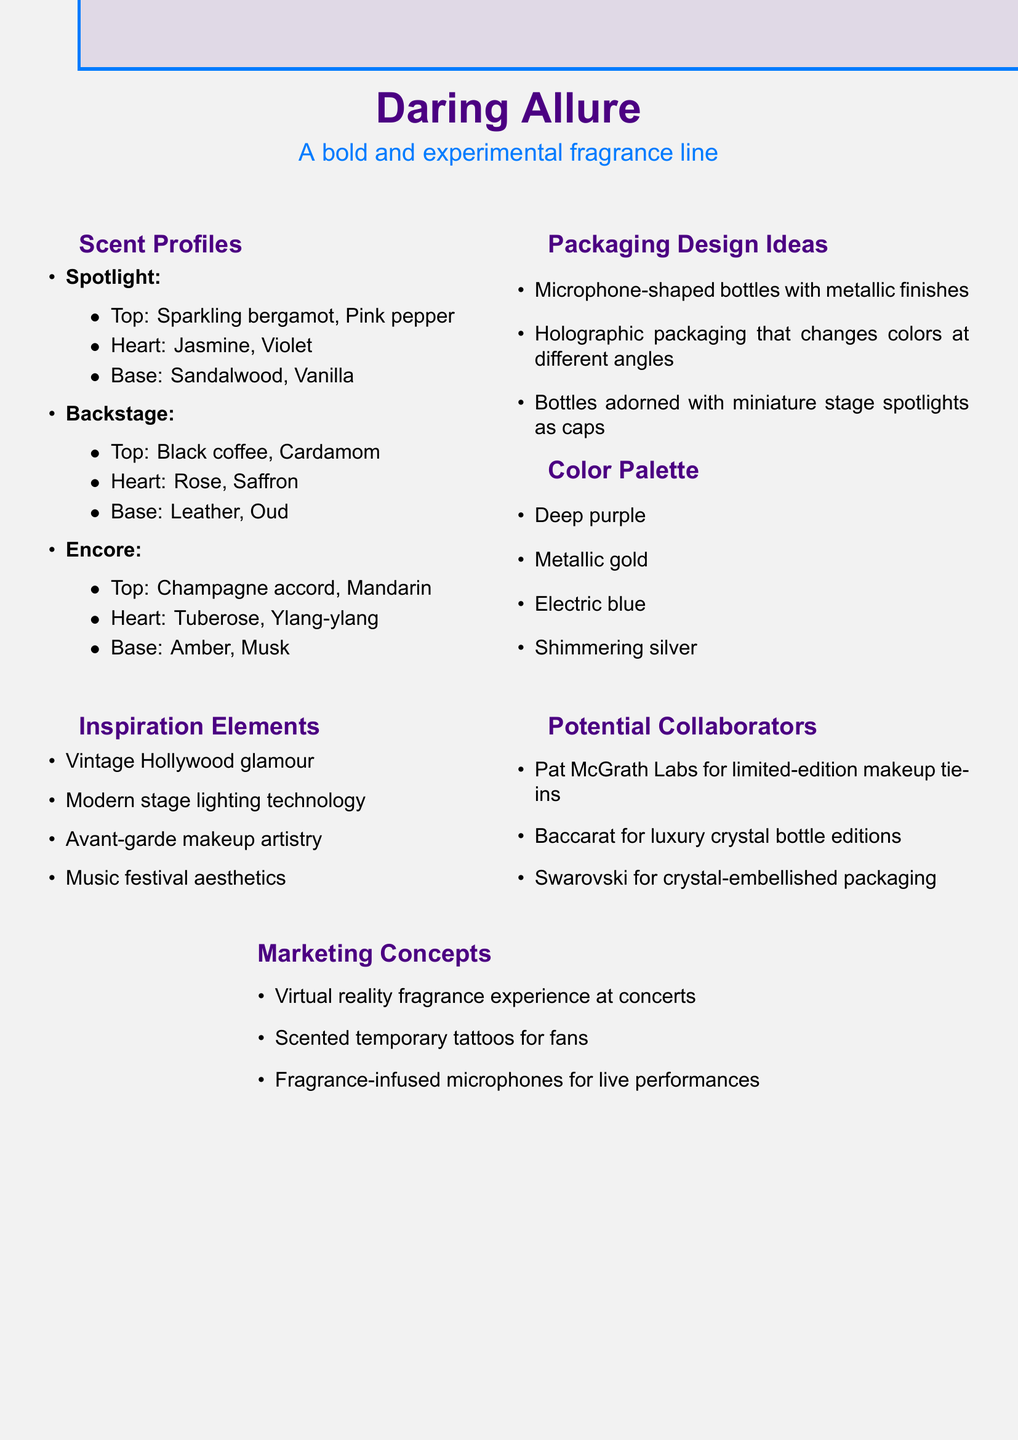What is the name of the fragrance line? The name of the fragrance line is presented prominently at the top of the document.
Answer: Daring Allure What are the top notes of the fragrance "Spotlight"? The top notes of "Spotlight" are found in the scent profiles section.
Answer: Sparkling bergamot, Pink pepper How many scent profiles are listed in the document? The number of scent profiles is determined by counting the items in the scent profiles section.
Answer: Three What is one of the packaging design ideas mentioned? A specific packaging design idea can be found in the packaging design ideas section.
Answer: Microphone-shaped bottles with metallic finishes Which color is included in the color palette? The color palette section lists several colors to choose from.
Answer: Deep purple What inspiration elements are mentioned? The inspiration elements section includes various artistic themes.
Answer: Vintage Hollywood glamour Who is a potential collaborator mentioned for the fragrance line? The potential collaborators section indicates potential partnerships for the project.
Answer: Pat McGrath Labs What marketing concept involves virtual reality? The marketing concepts section describes innovative marketing ideas for the fragrance line.
Answer: Virtual reality fragrance experience at concerts What is the base note of the fragrance "Backstage"? The base notes of "Backstage" can be found within the scent profiles section.
Answer: Leather, Oud 